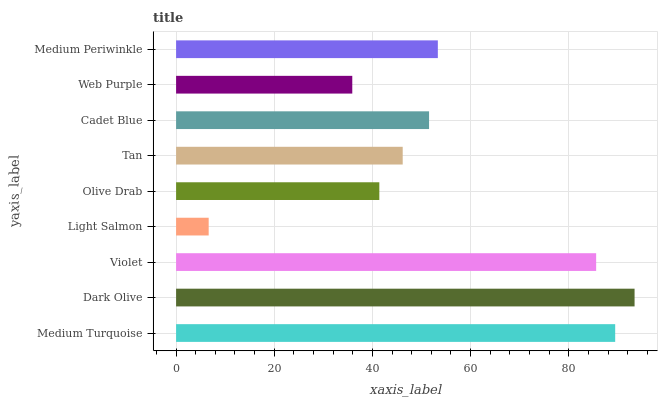Is Light Salmon the minimum?
Answer yes or no. Yes. Is Dark Olive the maximum?
Answer yes or no. Yes. Is Violet the minimum?
Answer yes or no. No. Is Violet the maximum?
Answer yes or no. No. Is Dark Olive greater than Violet?
Answer yes or no. Yes. Is Violet less than Dark Olive?
Answer yes or no. Yes. Is Violet greater than Dark Olive?
Answer yes or no. No. Is Dark Olive less than Violet?
Answer yes or no. No. Is Cadet Blue the high median?
Answer yes or no. Yes. Is Cadet Blue the low median?
Answer yes or no. Yes. Is Violet the high median?
Answer yes or no. No. Is Light Salmon the low median?
Answer yes or no. No. 